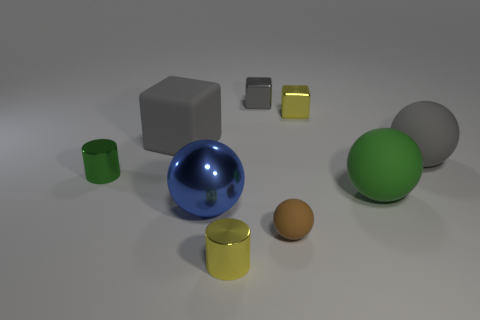Is there any object that stands out to you the most? The blue sphere stands out due to its glossy finish and larger size compared to the other objects in the image. What does the reflection on the sphere suggest about the environment? The reflection on the blue sphere's surface suggests a light source above the objects, likely illuminating the scene, and reveals a hint of the room's setting, although specific details are not visible. 